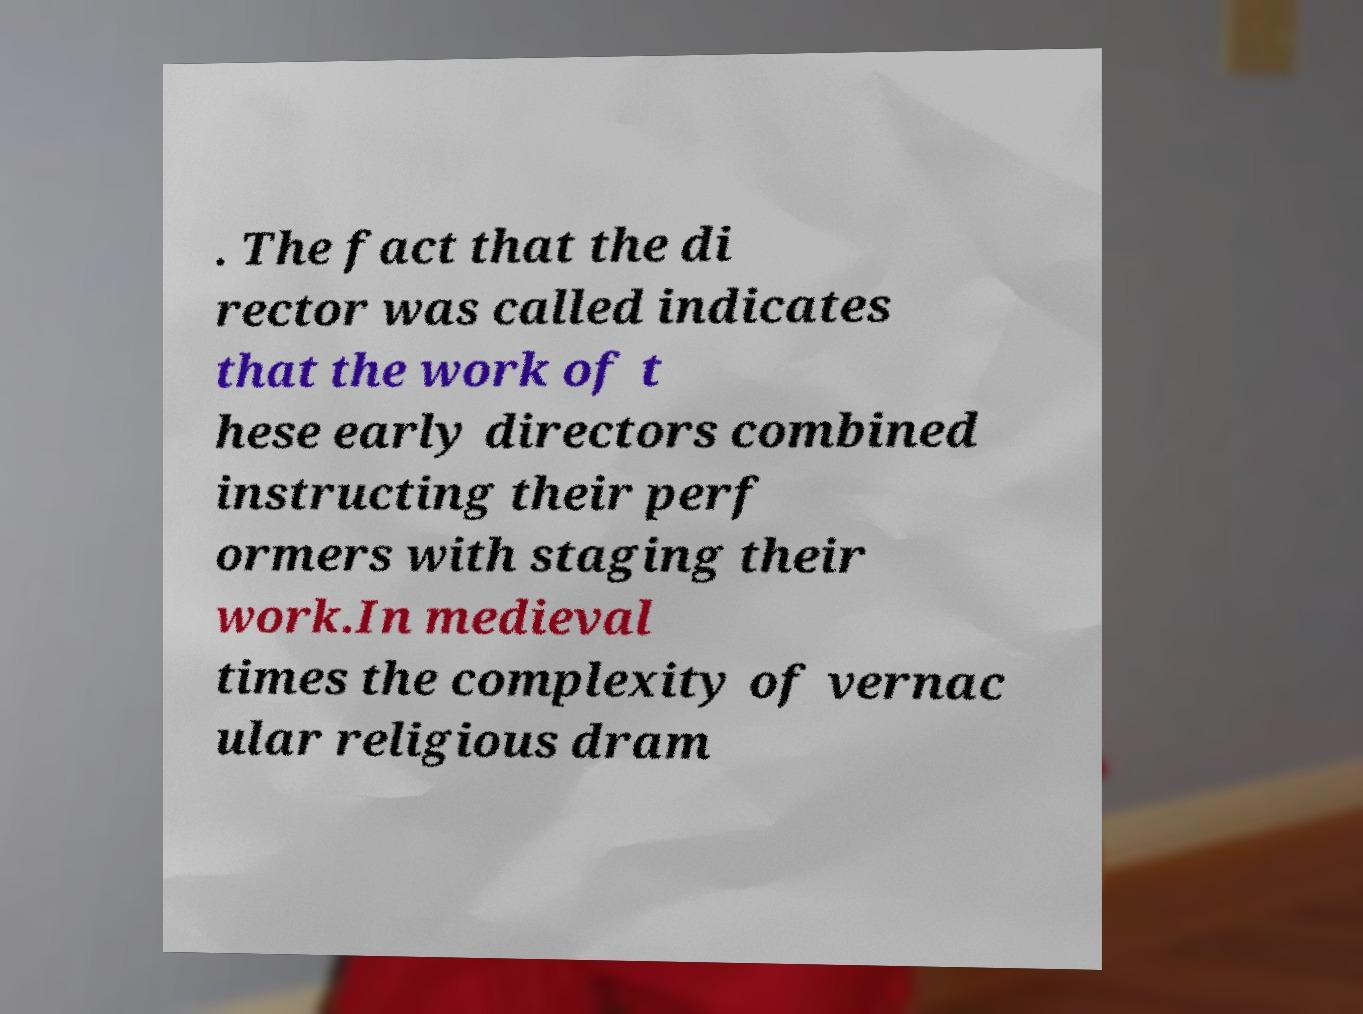I need the written content from this picture converted into text. Can you do that? . The fact that the di rector was called indicates that the work of t hese early directors combined instructing their perf ormers with staging their work.In medieval times the complexity of vernac ular religious dram 